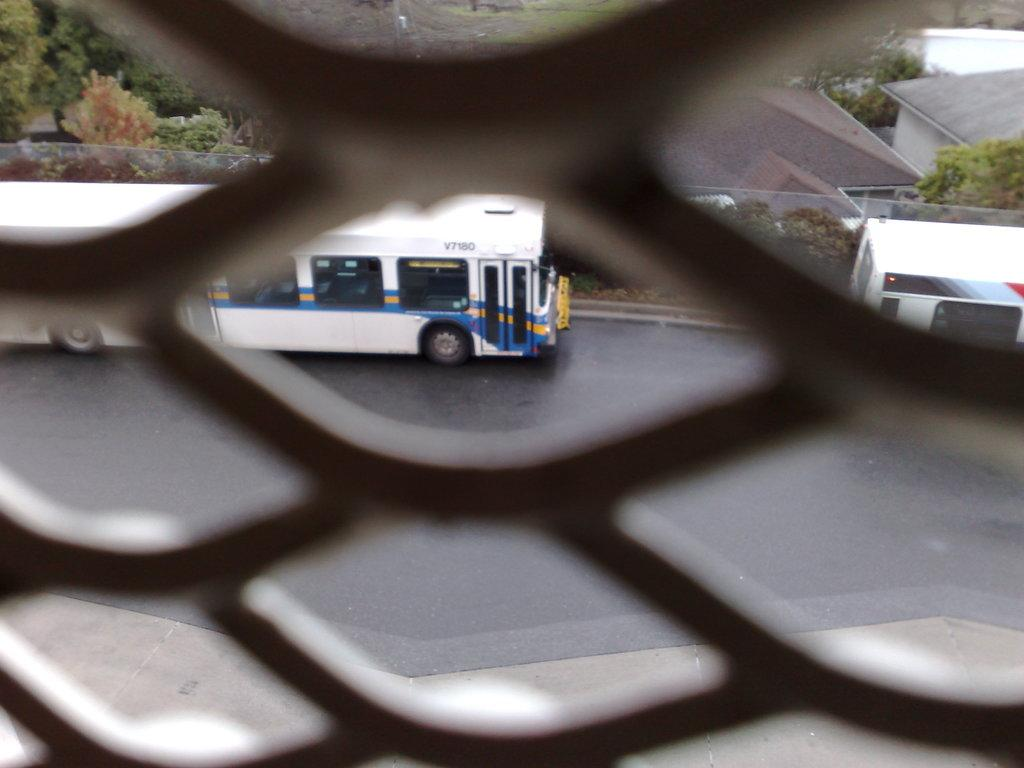What is the main feature of the image? There is a mesh in the image. What can be seen through the mesh? Trees, a road, a bus, buildings, and a pavement are visible through the mesh. How many different elements can be seen through the mesh? Five different elements can be seen through the mesh: trees, a road, a bus, buildings, and a pavement. What type of account is being discussed in the image? There is no account being discussed in the image; it features a mesh with various elements visible through it. Can you describe the texture of the chicken in the image? There is no chicken present in the image, so it is not possible to describe its texture. 